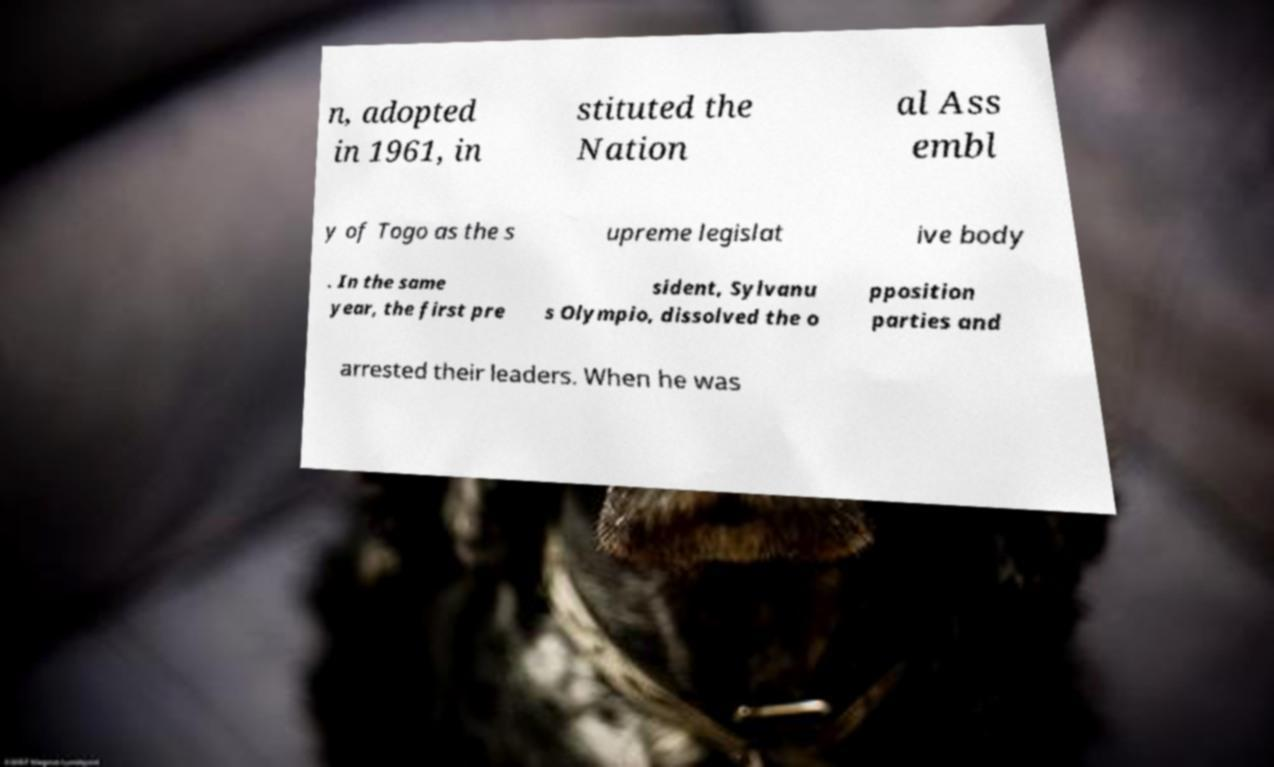Could you assist in decoding the text presented in this image and type it out clearly? n, adopted in 1961, in stituted the Nation al Ass embl y of Togo as the s upreme legislat ive body . In the same year, the first pre sident, Sylvanu s Olympio, dissolved the o pposition parties and arrested their leaders. When he was 